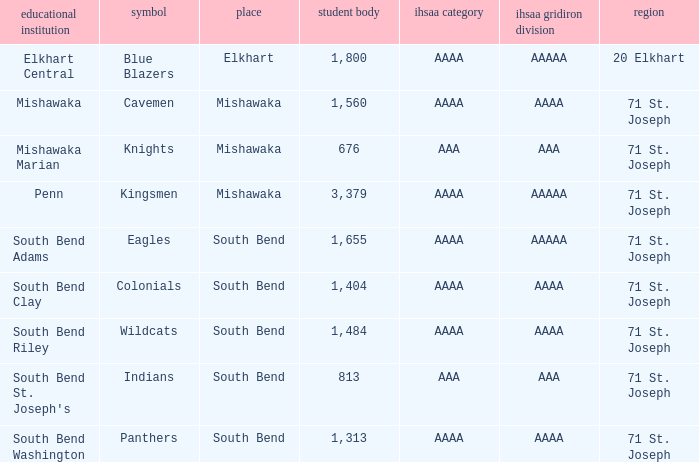What location has kingsmen as the mascot? Mishawaka. 